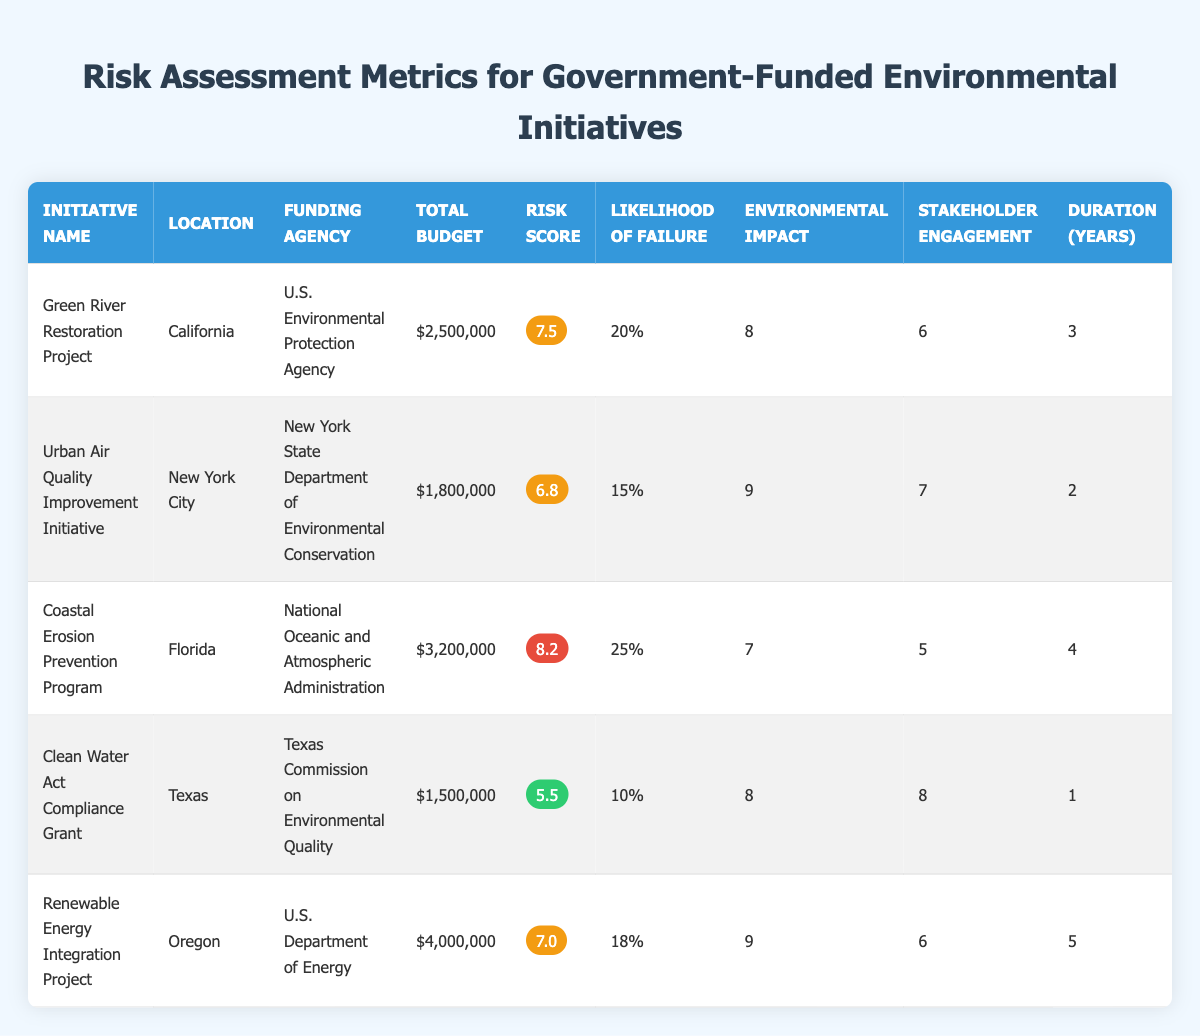What is the total budget for the Coastal Erosion Prevention Program? The total budget for the Coastal Erosion Prevention Program can be found in the table under the "Total Budget" column. The amount listed is $3,200,000.
Answer: $3,200,000 Which project has the highest risk score? By scanning the "Risk Score" column, we see that the Coastal Erosion Prevention Program has the highest score of 8.2.
Answer: Coastal Erosion Prevention Program What is the average likelihood of failure across all initiatives? The likelihood of failure for each initiative is 0.2, 0.15, 0.25, 0.1, and 0.18. First, we sum these values: 0.2 + 0.15 + 0.25 + 0.1 + 0.18 = 0.88. There are 5 initiatives, so we divide by 5: 0.88 / 5 = 0.176.
Answer: 0.176 Is the Clean Water Act Compliance Grant considered high risk? The risk score for the Clean Water Act Compliance Grant is 5.5, which falls under the medium to low range. Thus, it is not considered high risk.
Answer: No Which initiative has the longest duration and what is that duration? By reviewing the "Duration (Years)" column, the Renewable Energy Integration Project has the longest duration of 5 years.
Answer: 5 years What is the potential environmental impact score of the Urban Air Quality Improvement Initiative? The potential environmental impact score for the Urban Air Quality Improvement Initiative is listed in the table under the "Environmental Impact" column, which indicates a score of 9.
Answer: 9 Are the stakeholder engagement scores for projects in California and Texas both above 5? The stakeholder engagement score for the Green River Restoration Project in California is 6, and for the Clean Water Act Compliance Grant in Texas, it is 8. Both scores are above 5.
Answer: Yes What is the difference in total budget between the Renewable Energy Integration Project and the Clean Water Act Compliance Grant? The total budget for the Renewable Energy Integration Project is $4,000,000 and for the Clean Water Act Compliance Grant, it is $1,500,000. Subtracting these gives: $4,000,000 - $1,500,000 = $2,500,000.
Answer: $2,500,000 What proportion of projects have a risk score greater than 7? The initiatives with a risk score greater than 7 are the Green River Restoration Project (7.5) and the Coastal Erosion Prevention Program (8.2), so there are 2 out of 5 projects. The proportion is 2/5 = 0.4.
Answer: 0.4 